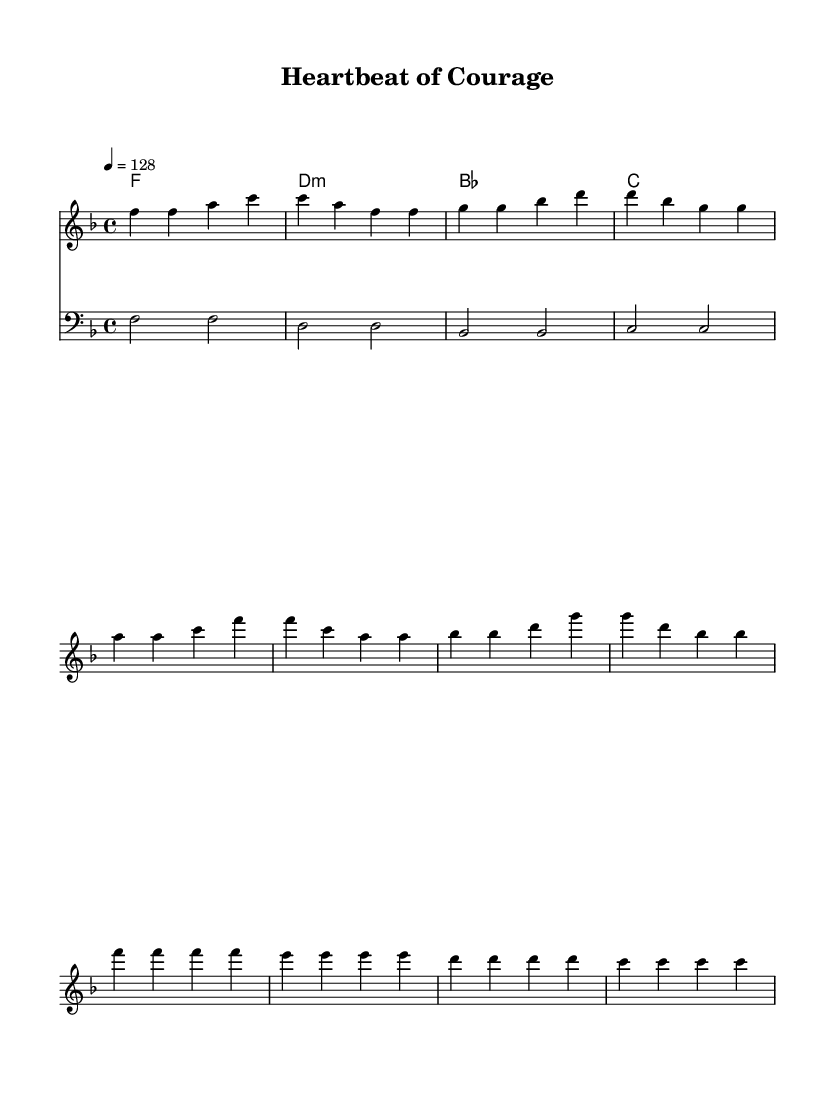What is the key signature of this music? The key signature is F major, which has one flat (B flat). You can determine this by counting the number of flats in the key signature area at the beginning of the staff.
Answer: F major What is the time signature of this music? The time signature is 4/4, which indicates that there are four beats in a measure and the quarter note gets one beat. This is shown at the beginning of the sheet music next to the key signature.
Answer: 4/4 What is the tempo marking of this music? The tempo marking is 128 beats per minute. This is indicated in the tempo instruction (4 = 128) at the start of the score, denoting the speed of the music.
Answer: 128 How many measures are in the verse section? The verse section has four measures, and this can be counted by looking at the notation for the verses, which are separated by vertical bar lines.
Answer: 4 What is the chord in the pre-chorus? The chord in the pre-chorus is F major, which can be found by looking at the harmony section indicating the chords above the melody line for that part.
Answer: F Which line in the song expresses strength? The line "I'm stronger than my worries" expresses strength, and this can be identified by analyzing the lyric content and the thematic focus on overcoming anxiety and worries.
Answer: I'm stronger than my worries What phrase indicates a sense of freedom in the chorus? The phrase "I'm healthy and I'm free" indicates a sense of freedom, as it articulates a release from anxiety, which is a key theme in upbeat House music. You can find this in the lyrics of the chorus.
Answer: I'm healthy and I'm free 